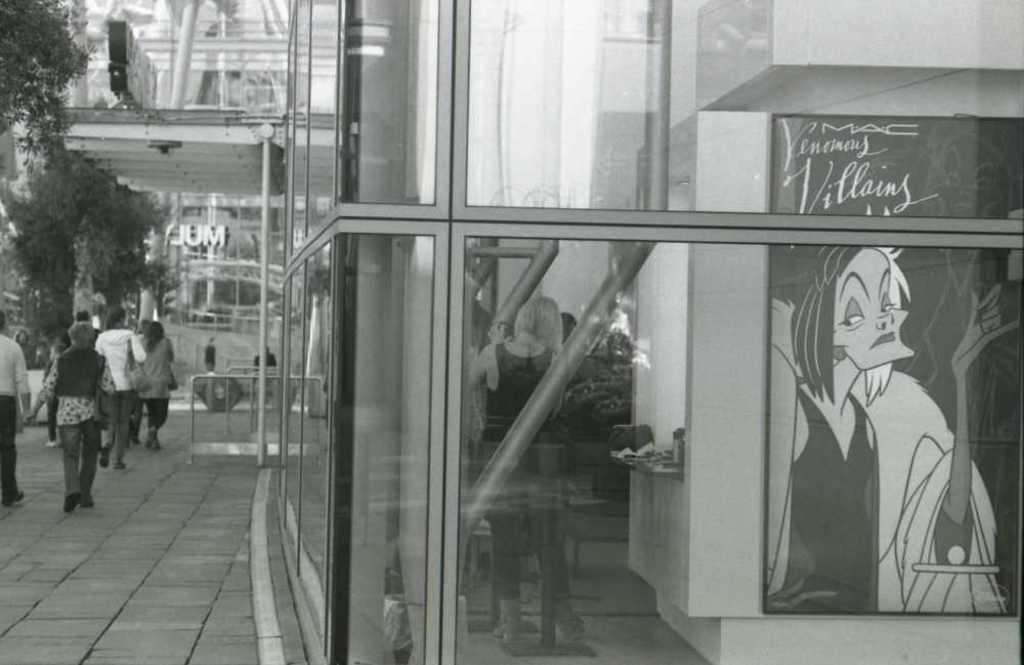What is the color scheme of the image? The image is black and white. What can be seen in the image besides the color scheme? There are people standing in the image. Where are the people standing? The people are standing on the floor. What else is visible in the image? There is a building and a wall hanging visible in the image. What type of berry is being used as a decoration on the wall hanging in the image? There is no berry present on the wall hanging in the image. Are there any slaves depicted in the image? The term "slave" is not mentioned or depicted in the image. 